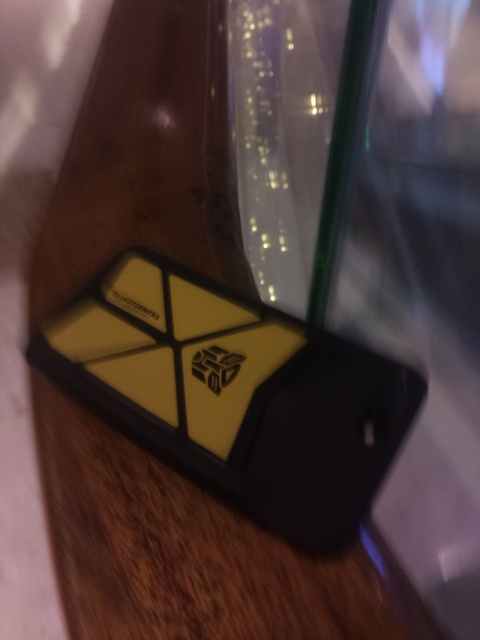Is there anything in the image that tells us about the setting or the owner's habits? The image shows the phone resting on a wooden surface with reflections of lights in the background, hinting that it may have been placed on a table or bar in a dimly lit environment, possibly suggesting a social setting or an outing. 